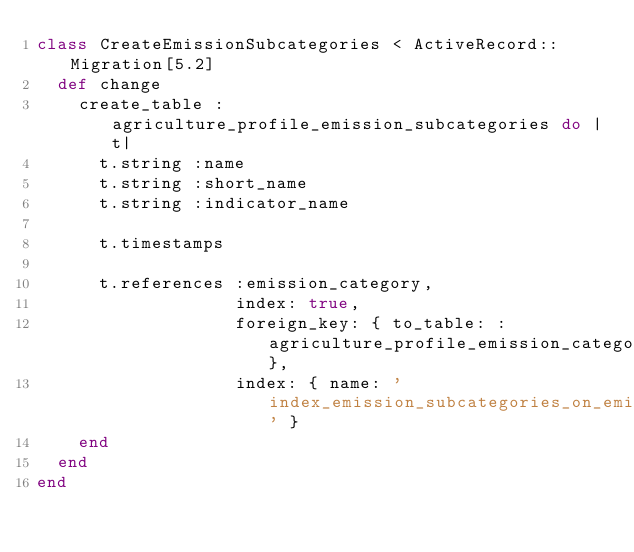<code> <loc_0><loc_0><loc_500><loc_500><_Ruby_>class CreateEmissionSubcategories < ActiveRecord::Migration[5.2]
  def change
    create_table :agriculture_profile_emission_subcategories do |t|
      t.string :name
      t.string :short_name
      t.string :indicator_name

      t.timestamps

      t.references :emission_category,
                   index: true,
                   foreign_key: { to_table: :agriculture_profile_emission_categories},
                   index: { name: 'index_emission_subcategories_on_emission_category_id' }
    end
  end
end
</code> 